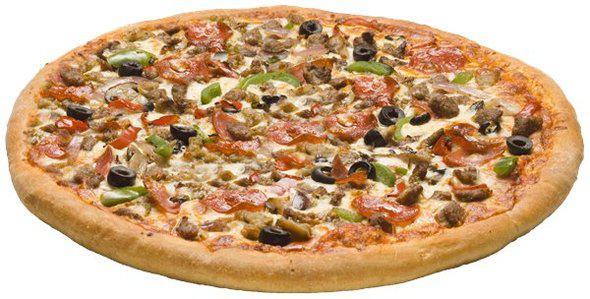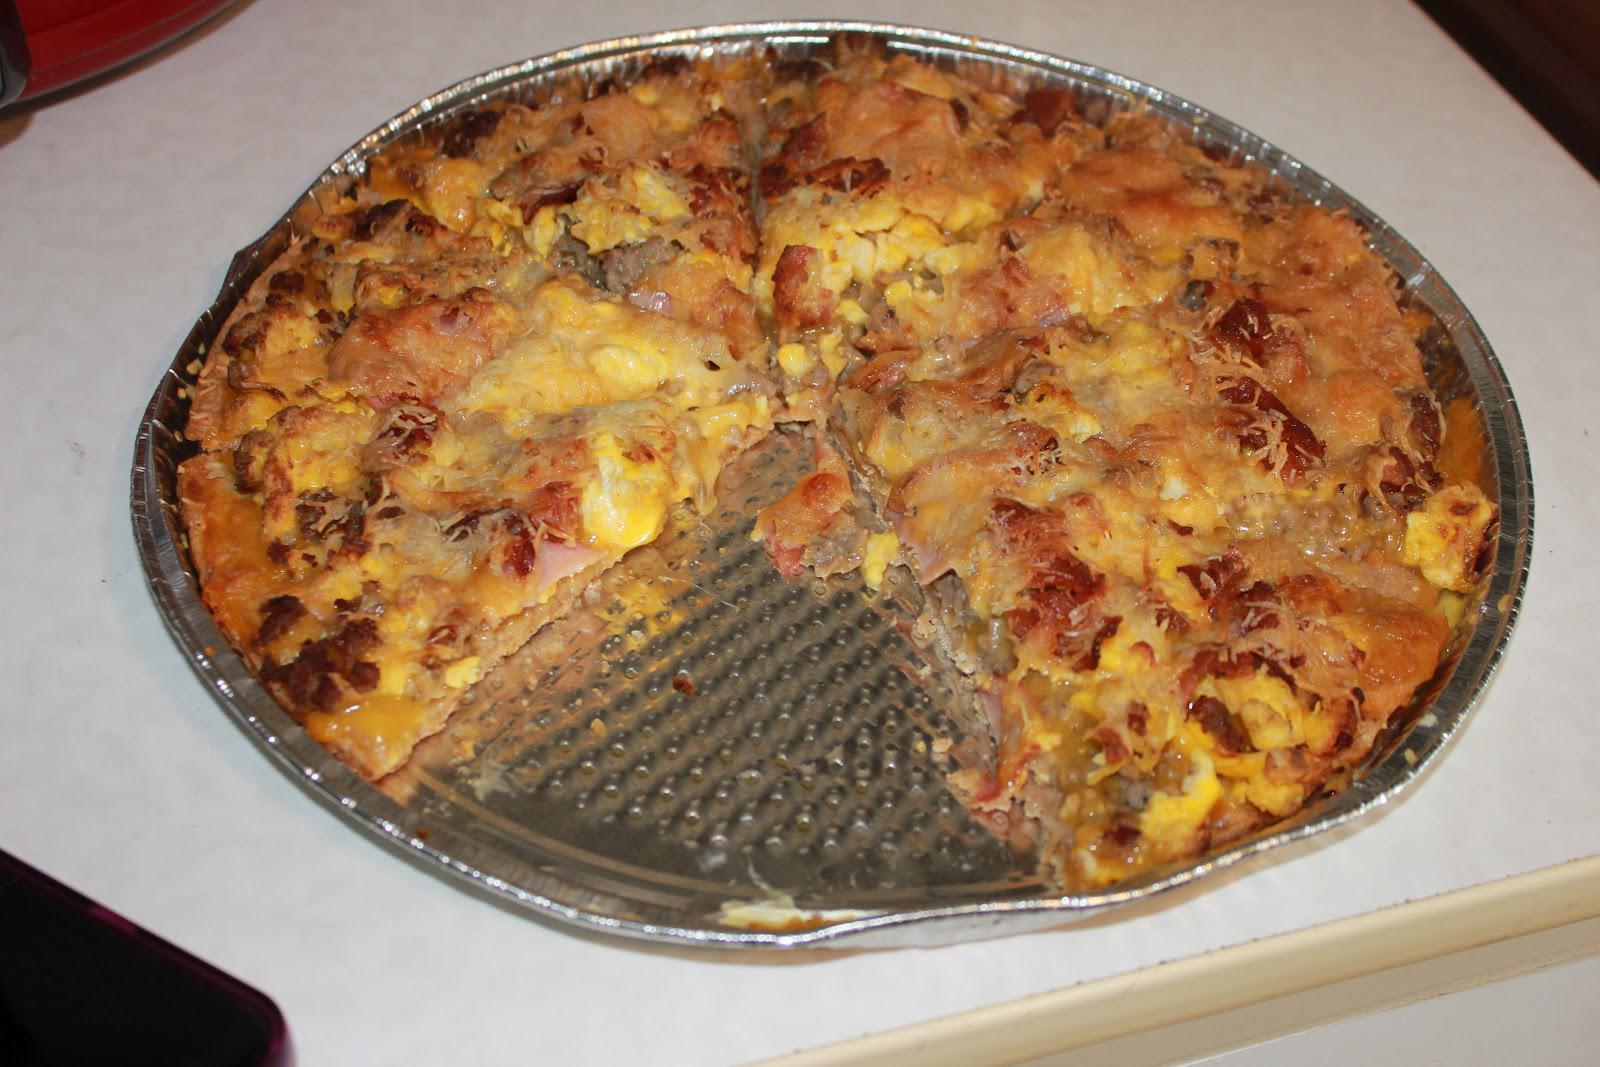The first image is the image on the left, the second image is the image on the right. Given the left and right images, does the statement "Two whole baked pizzas are covered with toppings and melted cheese, one of them in a cardboard delivery box." hold true? Answer yes or no. No. The first image is the image on the left, the second image is the image on the right. Given the left and right images, does the statement "there is a pizza in a carboard box" hold true? Answer yes or no. No. 